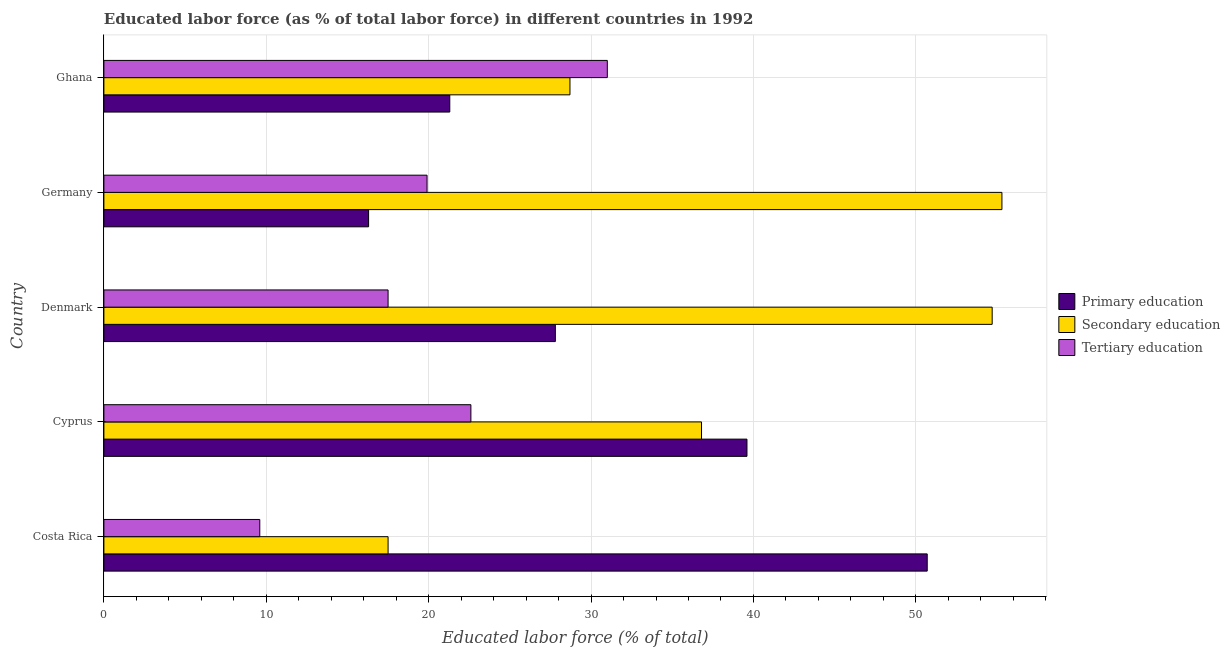How many groups of bars are there?
Give a very brief answer. 5. Are the number of bars per tick equal to the number of legend labels?
Make the answer very short. Yes. Are the number of bars on each tick of the Y-axis equal?
Make the answer very short. Yes. How many bars are there on the 4th tick from the top?
Offer a very short reply. 3. What is the label of the 1st group of bars from the top?
Provide a succinct answer. Ghana. In how many cases, is the number of bars for a given country not equal to the number of legend labels?
Give a very brief answer. 0. What is the percentage of labor force who received primary education in Germany?
Offer a very short reply. 16.3. Across all countries, what is the maximum percentage of labor force who received primary education?
Provide a short and direct response. 50.7. Across all countries, what is the minimum percentage of labor force who received tertiary education?
Offer a very short reply. 9.6. In which country was the percentage of labor force who received tertiary education minimum?
Make the answer very short. Costa Rica. What is the total percentage of labor force who received secondary education in the graph?
Your answer should be compact. 193. What is the difference between the percentage of labor force who received secondary education in Cyprus and that in Denmark?
Provide a short and direct response. -17.9. What is the difference between the percentage of labor force who received primary education in Cyprus and the percentage of labor force who received secondary education in Denmark?
Provide a short and direct response. -15.1. What is the average percentage of labor force who received primary education per country?
Your answer should be compact. 31.14. What is the ratio of the percentage of labor force who received tertiary education in Cyprus to that in Germany?
Give a very brief answer. 1.14. What is the difference between the highest and the second highest percentage of labor force who received primary education?
Your response must be concise. 11.1. What is the difference between the highest and the lowest percentage of labor force who received secondary education?
Offer a terse response. 37.8. In how many countries, is the percentage of labor force who received primary education greater than the average percentage of labor force who received primary education taken over all countries?
Offer a terse response. 2. Is the sum of the percentage of labor force who received secondary education in Denmark and Germany greater than the maximum percentage of labor force who received primary education across all countries?
Provide a succinct answer. Yes. What does the 2nd bar from the top in Ghana represents?
Make the answer very short. Secondary education. What does the 3rd bar from the bottom in Denmark represents?
Offer a terse response. Tertiary education. Are all the bars in the graph horizontal?
Offer a very short reply. Yes. What is the difference between two consecutive major ticks on the X-axis?
Your answer should be compact. 10. Where does the legend appear in the graph?
Give a very brief answer. Center right. How many legend labels are there?
Offer a very short reply. 3. How are the legend labels stacked?
Offer a terse response. Vertical. What is the title of the graph?
Your answer should be very brief. Educated labor force (as % of total labor force) in different countries in 1992. What is the label or title of the X-axis?
Keep it short and to the point. Educated labor force (% of total). What is the Educated labor force (% of total) of Primary education in Costa Rica?
Your answer should be very brief. 50.7. What is the Educated labor force (% of total) of Secondary education in Costa Rica?
Your response must be concise. 17.5. What is the Educated labor force (% of total) in Tertiary education in Costa Rica?
Your response must be concise. 9.6. What is the Educated labor force (% of total) in Primary education in Cyprus?
Your answer should be compact. 39.6. What is the Educated labor force (% of total) of Secondary education in Cyprus?
Ensure brevity in your answer.  36.8. What is the Educated labor force (% of total) in Tertiary education in Cyprus?
Provide a short and direct response. 22.6. What is the Educated labor force (% of total) of Primary education in Denmark?
Keep it short and to the point. 27.8. What is the Educated labor force (% of total) in Secondary education in Denmark?
Your response must be concise. 54.7. What is the Educated labor force (% of total) of Primary education in Germany?
Your answer should be compact. 16.3. What is the Educated labor force (% of total) of Secondary education in Germany?
Keep it short and to the point. 55.3. What is the Educated labor force (% of total) in Tertiary education in Germany?
Provide a short and direct response. 19.9. What is the Educated labor force (% of total) in Primary education in Ghana?
Your answer should be very brief. 21.3. What is the Educated labor force (% of total) of Secondary education in Ghana?
Your response must be concise. 28.7. Across all countries, what is the maximum Educated labor force (% of total) of Primary education?
Offer a very short reply. 50.7. Across all countries, what is the maximum Educated labor force (% of total) of Secondary education?
Keep it short and to the point. 55.3. Across all countries, what is the minimum Educated labor force (% of total) of Primary education?
Give a very brief answer. 16.3. Across all countries, what is the minimum Educated labor force (% of total) of Tertiary education?
Keep it short and to the point. 9.6. What is the total Educated labor force (% of total) of Primary education in the graph?
Give a very brief answer. 155.7. What is the total Educated labor force (% of total) in Secondary education in the graph?
Your answer should be very brief. 193. What is the total Educated labor force (% of total) of Tertiary education in the graph?
Provide a short and direct response. 100.6. What is the difference between the Educated labor force (% of total) of Secondary education in Costa Rica and that in Cyprus?
Offer a very short reply. -19.3. What is the difference between the Educated labor force (% of total) of Tertiary education in Costa Rica and that in Cyprus?
Your response must be concise. -13. What is the difference between the Educated labor force (% of total) in Primary education in Costa Rica and that in Denmark?
Keep it short and to the point. 22.9. What is the difference between the Educated labor force (% of total) of Secondary education in Costa Rica and that in Denmark?
Offer a terse response. -37.2. What is the difference between the Educated labor force (% of total) of Tertiary education in Costa Rica and that in Denmark?
Your response must be concise. -7.9. What is the difference between the Educated labor force (% of total) in Primary education in Costa Rica and that in Germany?
Keep it short and to the point. 34.4. What is the difference between the Educated labor force (% of total) of Secondary education in Costa Rica and that in Germany?
Offer a terse response. -37.8. What is the difference between the Educated labor force (% of total) of Tertiary education in Costa Rica and that in Germany?
Make the answer very short. -10.3. What is the difference between the Educated labor force (% of total) of Primary education in Costa Rica and that in Ghana?
Your response must be concise. 29.4. What is the difference between the Educated labor force (% of total) of Tertiary education in Costa Rica and that in Ghana?
Give a very brief answer. -21.4. What is the difference between the Educated labor force (% of total) of Primary education in Cyprus and that in Denmark?
Your response must be concise. 11.8. What is the difference between the Educated labor force (% of total) in Secondary education in Cyprus and that in Denmark?
Your answer should be compact. -17.9. What is the difference between the Educated labor force (% of total) in Primary education in Cyprus and that in Germany?
Provide a succinct answer. 23.3. What is the difference between the Educated labor force (% of total) of Secondary education in Cyprus and that in Germany?
Keep it short and to the point. -18.5. What is the difference between the Educated labor force (% of total) of Primary education in Cyprus and that in Ghana?
Provide a succinct answer. 18.3. What is the difference between the Educated labor force (% of total) of Primary education in Denmark and that in Germany?
Provide a short and direct response. 11.5. What is the difference between the Educated labor force (% of total) of Secondary education in Denmark and that in Germany?
Ensure brevity in your answer.  -0.6. What is the difference between the Educated labor force (% of total) in Secondary education in Denmark and that in Ghana?
Keep it short and to the point. 26. What is the difference between the Educated labor force (% of total) in Tertiary education in Denmark and that in Ghana?
Ensure brevity in your answer.  -13.5. What is the difference between the Educated labor force (% of total) of Primary education in Germany and that in Ghana?
Provide a succinct answer. -5. What is the difference between the Educated labor force (% of total) of Secondary education in Germany and that in Ghana?
Your answer should be compact. 26.6. What is the difference between the Educated labor force (% of total) in Tertiary education in Germany and that in Ghana?
Your response must be concise. -11.1. What is the difference between the Educated labor force (% of total) in Primary education in Costa Rica and the Educated labor force (% of total) in Secondary education in Cyprus?
Provide a short and direct response. 13.9. What is the difference between the Educated labor force (% of total) in Primary education in Costa Rica and the Educated labor force (% of total) in Tertiary education in Cyprus?
Ensure brevity in your answer.  28.1. What is the difference between the Educated labor force (% of total) in Primary education in Costa Rica and the Educated labor force (% of total) in Secondary education in Denmark?
Your response must be concise. -4. What is the difference between the Educated labor force (% of total) of Primary education in Costa Rica and the Educated labor force (% of total) of Tertiary education in Denmark?
Offer a terse response. 33.2. What is the difference between the Educated labor force (% of total) of Secondary education in Costa Rica and the Educated labor force (% of total) of Tertiary education in Denmark?
Ensure brevity in your answer.  0. What is the difference between the Educated labor force (% of total) of Primary education in Costa Rica and the Educated labor force (% of total) of Tertiary education in Germany?
Offer a terse response. 30.8. What is the difference between the Educated labor force (% of total) in Secondary education in Costa Rica and the Educated labor force (% of total) in Tertiary education in Germany?
Offer a very short reply. -2.4. What is the difference between the Educated labor force (% of total) in Primary education in Costa Rica and the Educated labor force (% of total) in Secondary education in Ghana?
Make the answer very short. 22. What is the difference between the Educated labor force (% of total) of Primary education in Costa Rica and the Educated labor force (% of total) of Tertiary education in Ghana?
Provide a short and direct response. 19.7. What is the difference between the Educated labor force (% of total) of Secondary education in Costa Rica and the Educated labor force (% of total) of Tertiary education in Ghana?
Offer a very short reply. -13.5. What is the difference between the Educated labor force (% of total) in Primary education in Cyprus and the Educated labor force (% of total) in Secondary education in Denmark?
Give a very brief answer. -15.1. What is the difference between the Educated labor force (% of total) in Primary education in Cyprus and the Educated labor force (% of total) in Tertiary education in Denmark?
Keep it short and to the point. 22.1. What is the difference between the Educated labor force (% of total) of Secondary education in Cyprus and the Educated labor force (% of total) of Tertiary education in Denmark?
Keep it short and to the point. 19.3. What is the difference between the Educated labor force (% of total) of Primary education in Cyprus and the Educated labor force (% of total) of Secondary education in Germany?
Offer a very short reply. -15.7. What is the difference between the Educated labor force (% of total) in Primary education in Cyprus and the Educated labor force (% of total) in Tertiary education in Germany?
Your answer should be compact. 19.7. What is the difference between the Educated labor force (% of total) in Secondary education in Cyprus and the Educated labor force (% of total) in Tertiary education in Germany?
Offer a terse response. 16.9. What is the difference between the Educated labor force (% of total) of Primary education in Cyprus and the Educated labor force (% of total) of Secondary education in Ghana?
Offer a very short reply. 10.9. What is the difference between the Educated labor force (% of total) in Primary education in Denmark and the Educated labor force (% of total) in Secondary education in Germany?
Make the answer very short. -27.5. What is the difference between the Educated labor force (% of total) in Secondary education in Denmark and the Educated labor force (% of total) in Tertiary education in Germany?
Keep it short and to the point. 34.8. What is the difference between the Educated labor force (% of total) of Primary education in Denmark and the Educated labor force (% of total) of Tertiary education in Ghana?
Ensure brevity in your answer.  -3.2. What is the difference between the Educated labor force (% of total) of Secondary education in Denmark and the Educated labor force (% of total) of Tertiary education in Ghana?
Make the answer very short. 23.7. What is the difference between the Educated labor force (% of total) in Primary education in Germany and the Educated labor force (% of total) in Tertiary education in Ghana?
Provide a short and direct response. -14.7. What is the difference between the Educated labor force (% of total) of Secondary education in Germany and the Educated labor force (% of total) of Tertiary education in Ghana?
Make the answer very short. 24.3. What is the average Educated labor force (% of total) in Primary education per country?
Your answer should be compact. 31.14. What is the average Educated labor force (% of total) in Secondary education per country?
Offer a very short reply. 38.6. What is the average Educated labor force (% of total) of Tertiary education per country?
Your response must be concise. 20.12. What is the difference between the Educated labor force (% of total) of Primary education and Educated labor force (% of total) of Secondary education in Costa Rica?
Provide a succinct answer. 33.2. What is the difference between the Educated labor force (% of total) in Primary education and Educated labor force (% of total) in Tertiary education in Costa Rica?
Provide a succinct answer. 41.1. What is the difference between the Educated labor force (% of total) in Secondary education and Educated labor force (% of total) in Tertiary education in Costa Rica?
Offer a very short reply. 7.9. What is the difference between the Educated labor force (% of total) in Primary education and Educated labor force (% of total) in Secondary education in Denmark?
Offer a terse response. -26.9. What is the difference between the Educated labor force (% of total) of Primary education and Educated labor force (% of total) of Tertiary education in Denmark?
Ensure brevity in your answer.  10.3. What is the difference between the Educated labor force (% of total) in Secondary education and Educated labor force (% of total) in Tertiary education in Denmark?
Provide a short and direct response. 37.2. What is the difference between the Educated labor force (% of total) of Primary education and Educated labor force (% of total) of Secondary education in Germany?
Give a very brief answer. -39. What is the difference between the Educated labor force (% of total) of Primary education and Educated labor force (% of total) of Tertiary education in Germany?
Keep it short and to the point. -3.6. What is the difference between the Educated labor force (% of total) in Secondary education and Educated labor force (% of total) in Tertiary education in Germany?
Make the answer very short. 35.4. What is the difference between the Educated labor force (% of total) of Primary education and Educated labor force (% of total) of Secondary education in Ghana?
Give a very brief answer. -7.4. What is the difference between the Educated labor force (% of total) of Primary education and Educated labor force (% of total) of Tertiary education in Ghana?
Offer a very short reply. -9.7. What is the ratio of the Educated labor force (% of total) in Primary education in Costa Rica to that in Cyprus?
Your answer should be compact. 1.28. What is the ratio of the Educated labor force (% of total) of Secondary education in Costa Rica to that in Cyprus?
Your response must be concise. 0.48. What is the ratio of the Educated labor force (% of total) in Tertiary education in Costa Rica to that in Cyprus?
Ensure brevity in your answer.  0.42. What is the ratio of the Educated labor force (% of total) of Primary education in Costa Rica to that in Denmark?
Give a very brief answer. 1.82. What is the ratio of the Educated labor force (% of total) in Secondary education in Costa Rica to that in Denmark?
Keep it short and to the point. 0.32. What is the ratio of the Educated labor force (% of total) of Tertiary education in Costa Rica to that in Denmark?
Ensure brevity in your answer.  0.55. What is the ratio of the Educated labor force (% of total) of Primary education in Costa Rica to that in Germany?
Your response must be concise. 3.11. What is the ratio of the Educated labor force (% of total) of Secondary education in Costa Rica to that in Germany?
Keep it short and to the point. 0.32. What is the ratio of the Educated labor force (% of total) of Tertiary education in Costa Rica to that in Germany?
Offer a very short reply. 0.48. What is the ratio of the Educated labor force (% of total) in Primary education in Costa Rica to that in Ghana?
Your response must be concise. 2.38. What is the ratio of the Educated labor force (% of total) of Secondary education in Costa Rica to that in Ghana?
Your answer should be compact. 0.61. What is the ratio of the Educated labor force (% of total) of Tertiary education in Costa Rica to that in Ghana?
Give a very brief answer. 0.31. What is the ratio of the Educated labor force (% of total) in Primary education in Cyprus to that in Denmark?
Provide a short and direct response. 1.42. What is the ratio of the Educated labor force (% of total) of Secondary education in Cyprus to that in Denmark?
Make the answer very short. 0.67. What is the ratio of the Educated labor force (% of total) of Tertiary education in Cyprus to that in Denmark?
Ensure brevity in your answer.  1.29. What is the ratio of the Educated labor force (% of total) of Primary education in Cyprus to that in Germany?
Your answer should be very brief. 2.43. What is the ratio of the Educated labor force (% of total) of Secondary education in Cyprus to that in Germany?
Keep it short and to the point. 0.67. What is the ratio of the Educated labor force (% of total) of Tertiary education in Cyprus to that in Germany?
Offer a terse response. 1.14. What is the ratio of the Educated labor force (% of total) in Primary education in Cyprus to that in Ghana?
Keep it short and to the point. 1.86. What is the ratio of the Educated labor force (% of total) of Secondary education in Cyprus to that in Ghana?
Your answer should be very brief. 1.28. What is the ratio of the Educated labor force (% of total) of Tertiary education in Cyprus to that in Ghana?
Your response must be concise. 0.73. What is the ratio of the Educated labor force (% of total) of Primary education in Denmark to that in Germany?
Make the answer very short. 1.71. What is the ratio of the Educated labor force (% of total) in Secondary education in Denmark to that in Germany?
Make the answer very short. 0.99. What is the ratio of the Educated labor force (% of total) of Tertiary education in Denmark to that in Germany?
Your answer should be very brief. 0.88. What is the ratio of the Educated labor force (% of total) of Primary education in Denmark to that in Ghana?
Provide a succinct answer. 1.31. What is the ratio of the Educated labor force (% of total) in Secondary education in Denmark to that in Ghana?
Ensure brevity in your answer.  1.91. What is the ratio of the Educated labor force (% of total) in Tertiary education in Denmark to that in Ghana?
Your response must be concise. 0.56. What is the ratio of the Educated labor force (% of total) of Primary education in Germany to that in Ghana?
Your response must be concise. 0.77. What is the ratio of the Educated labor force (% of total) in Secondary education in Germany to that in Ghana?
Give a very brief answer. 1.93. What is the ratio of the Educated labor force (% of total) in Tertiary education in Germany to that in Ghana?
Offer a very short reply. 0.64. What is the difference between the highest and the second highest Educated labor force (% of total) in Primary education?
Your response must be concise. 11.1. What is the difference between the highest and the second highest Educated labor force (% of total) in Secondary education?
Offer a very short reply. 0.6. What is the difference between the highest and the lowest Educated labor force (% of total) of Primary education?
Your answer should be compact. 34.4. What is the difference between the highest and the lowest Educated labor force (% of total) in Secondary education?
Your answer should be compact. 37.8. What is the difference between the highest and the lowest Educated labor force (% of total) of Tertiary education?
Your answer should be very brief. 21.4. 